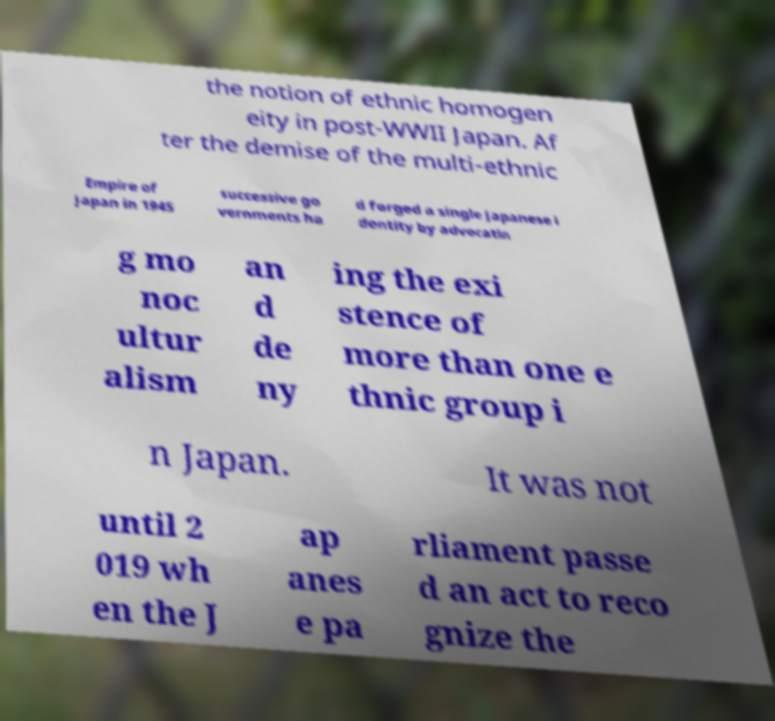Can you read and provide the text displayed in the image?This photo seems to have some interesting text. Can you extract and type it out for me? the notion of ethnic homogen eity in post-WWII Japan. Af ter the demise of the multi-ethnic Empire of Japan in 1945 successive go vernments ha d forged a single Japanese i dentity by advocatin g mo noc ultur alism an d de ny ing the exi stence of more than one e thnic group i n Japan. It was not until 2 019 wh en the J ap anes e pa rliament passe d an act to reco gnize the 